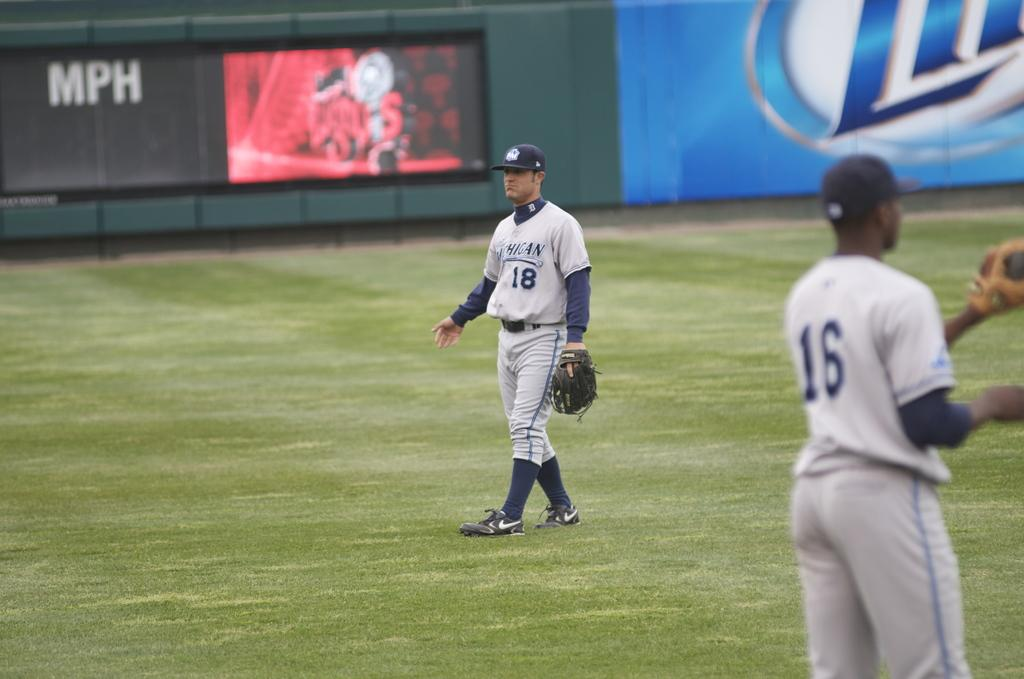<image>
Summarize the visual content of the image. A baseball field with a lite beer ad in the background. 